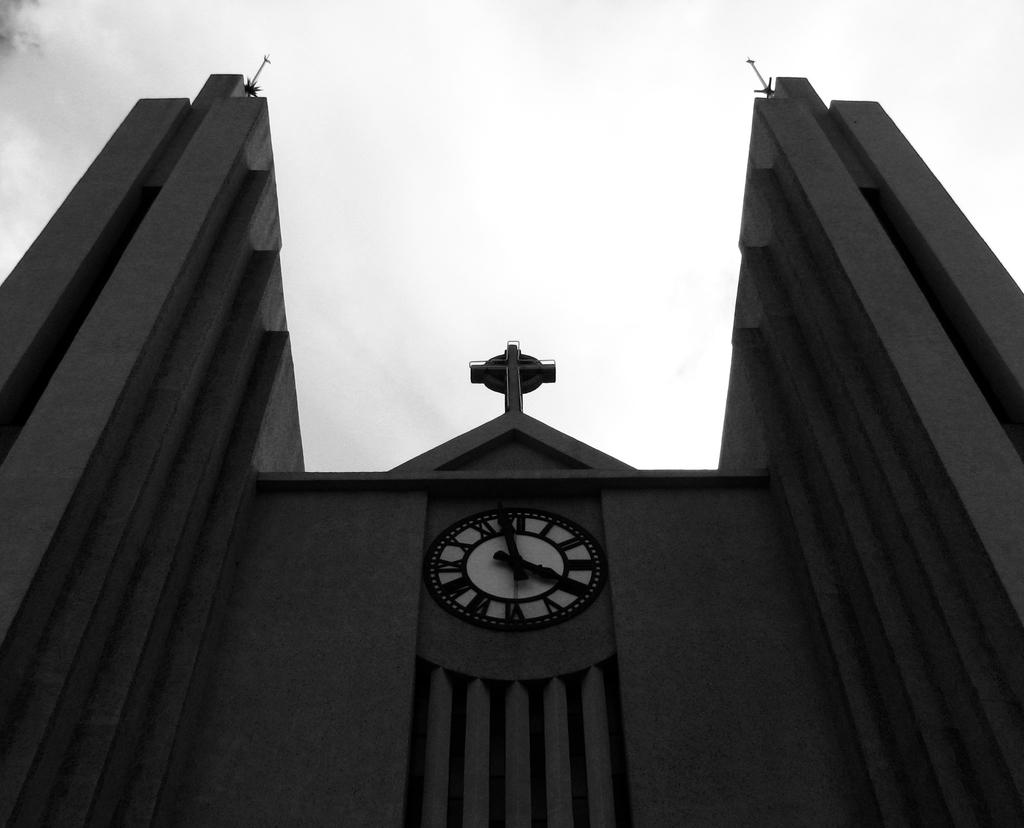What type of building is the main subject of the image? There is a clock tower building in the image. Can you describe the architectural style or features of the building? The provided facts do not include specific details about the building's style or features. Is there any indication of the time of day or year in the image? The presence of a clock tower might suggest that the time is visible, but the provided facts do not specify this. What type of match is being played in the image? There is no match or any indication of a game being played in the image; it features a clock tower building. How does the anger of the people in the image manifest itself? There are no people present in the image, and therefore no emotions can be observed. 